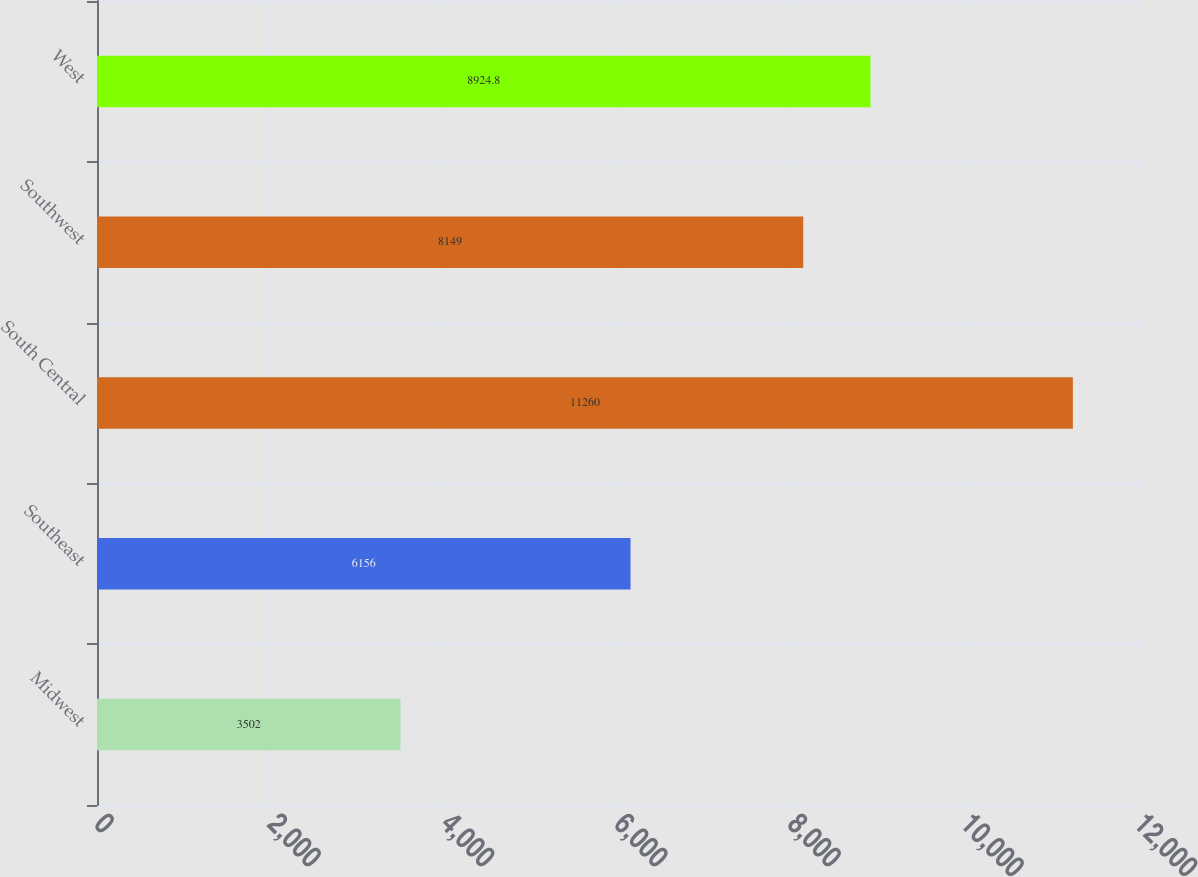<chart> <loc_0><loc_0><loc_500><loc_500><bar_chart><fcel>Midwest<fcel>Southeast<fcel>South Central<fcel>Southwest<fcel>West<nl><fcel>3502<fcel>6156<fcel>11260<fcel>8149<fcel>8924.8<nl></chart> 